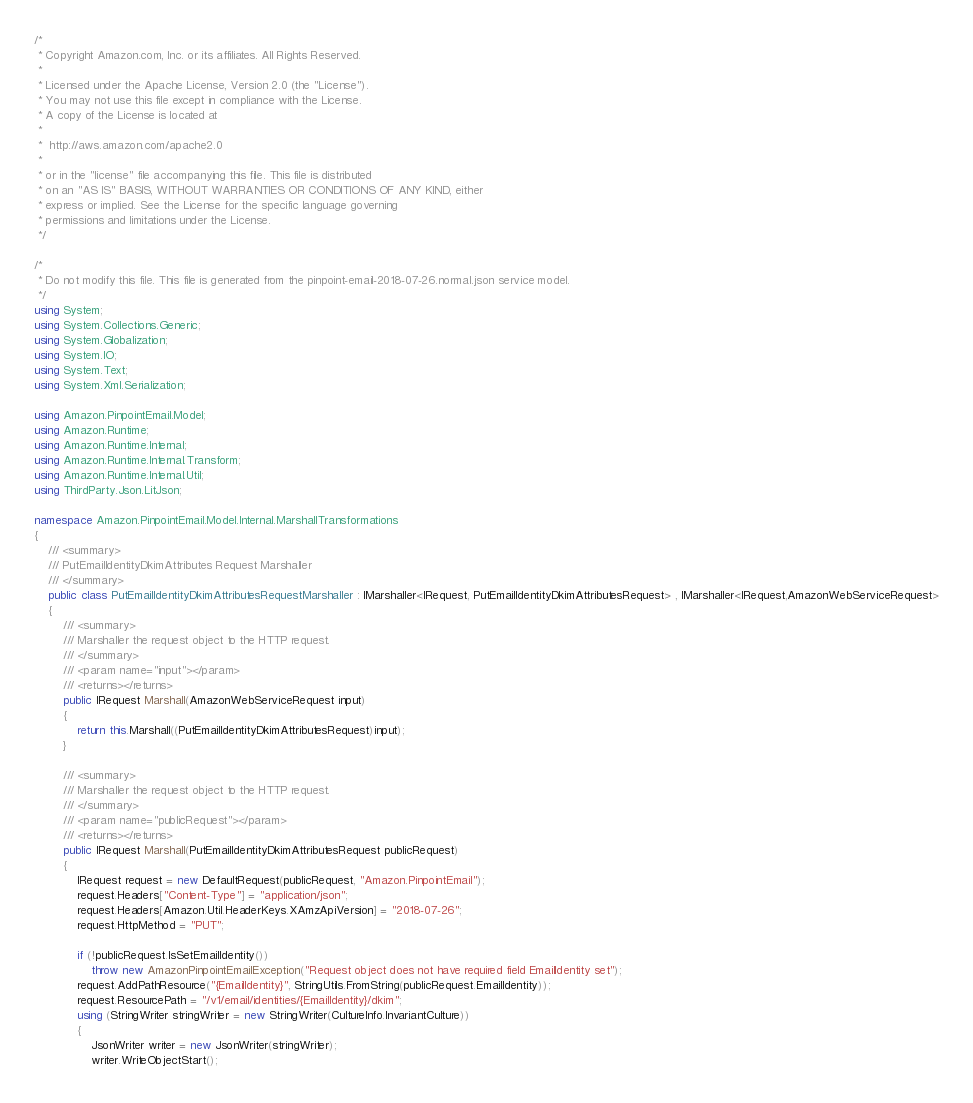<code> <loc_0><loc_0><loc_500><loc_500><_C#_>/*
 * Copyright Amazon.com, Inc. or its affiliates. All Rights Reserved.
 * 
 * Licensed under the Apache License, Version 2.0 (the "License").
 * You may not use this file except in compliance with the License.
 * A copy of the License is located at
 * 
 *  http://aws.amazon.com/apache2.0
 * 
 * or in the "license" file accompanying this file. This file is distributed
 * on an "AS IS" BASIS, WITHOUT WARRANTIES OR CONDITIONS OF ANY KIND, either
 * express or implied. See the License for the specific language governing
 * permissions and limitations under the License.
 */

/*
 * Do not modify this file. This file is generated from the pinpoint-email-2018-07-26.normal.json service model.
 */
using System;
using System.Collections.Generic;
using System.Globalization;
using System.IO;
using System.Text;
using System.Xml.Serialization;

using Amazon.PinpointEmail.Model;
using Amazon.Runtime;
using Amazon.Runtime.Internal;
using Amazon.Runtime.Internal.Transform;
using Amazon.Runtime.Internal.Util;
using ThirdParty.Json.LitJson;

namespace Amazon.PinpointEmail.Model.Internal.MarshallTransformations
{
    /// <summary>
    /// PutEmailIdentityDkimAttributes Request Marshaller
    /// </summary>       
    public class PutEmailIdentityDkimAttributesRequestMarshaller : IMarshaller<IRequest, PutEmailIdentityDkimAttributesRequest> , IMarshaller<IRequest,AmazonWebServiceRequest>
    {
        /// <summary>
        /// Marshaller the request object to the HTTP request.
        /// </summary>  
        /// <param name="input"></param>
        /// <returns></returns>
        public IRequest Marshall(AmazonWebServiceRequest input)
        {
            return this.Marshall((PutEmailIdentityDkimAttributesRequest)input);
        }

        /// <summary>
        /// Marshaller the request object to the HTTP request.
        /// </summary>  
        /// <param name="publicRequest"></param>
        /// <returns></returns>
        public IRequest Marshall(PutEmailIdentityDkimAttributesRequest publicRequest)
        {
            IRequest request = new DefaultRequest(publicRequest, "Amazon.PinpointEmail");
            request.Headers["Content-Type"] = "application/json";
            request.Headers[Amazon.Util.HeaderKeys.XAmzApiVersion] = "2018-07-26";
            request.HttpMethod = "PUT";

            if (!publicRequest.IsSetEmailIdentity())
                throw new AmazonPinpointEmailException("Request object does not have required field EmailIdentity set");
            request.AddPathResource("{EmailIdentity}", StringUtils.FromString(publicRequest.EmailIdentity));
            request.ResourcePath = "/v1/email/identities/{EmailIdentity}/dkim";
            using (StringWriter stringWriter = new StringWriter(CultureInfo.InvariantCulture))
            {
                JsonWriter writer = new JsonWriter(stringWriter);
                writer.WriteObjectStart();</code> 